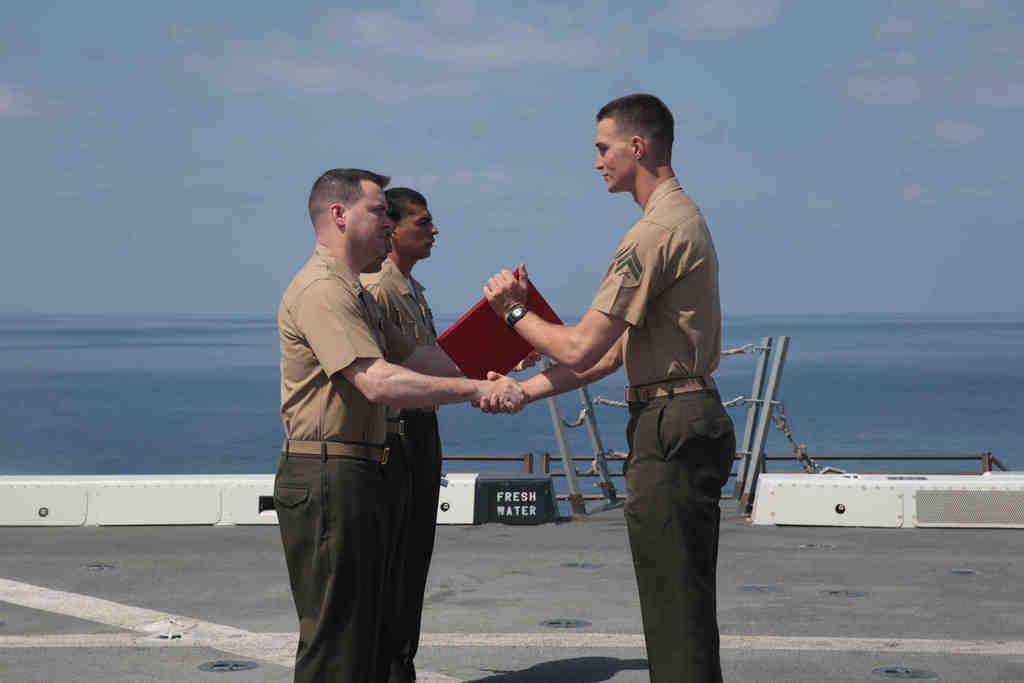How would you summarize this image in a sentence or two? In this image I can see a three persons and holding a red color object. Back I can see water and white and black board. I can see poles and chains. The sky is blue and white color. 